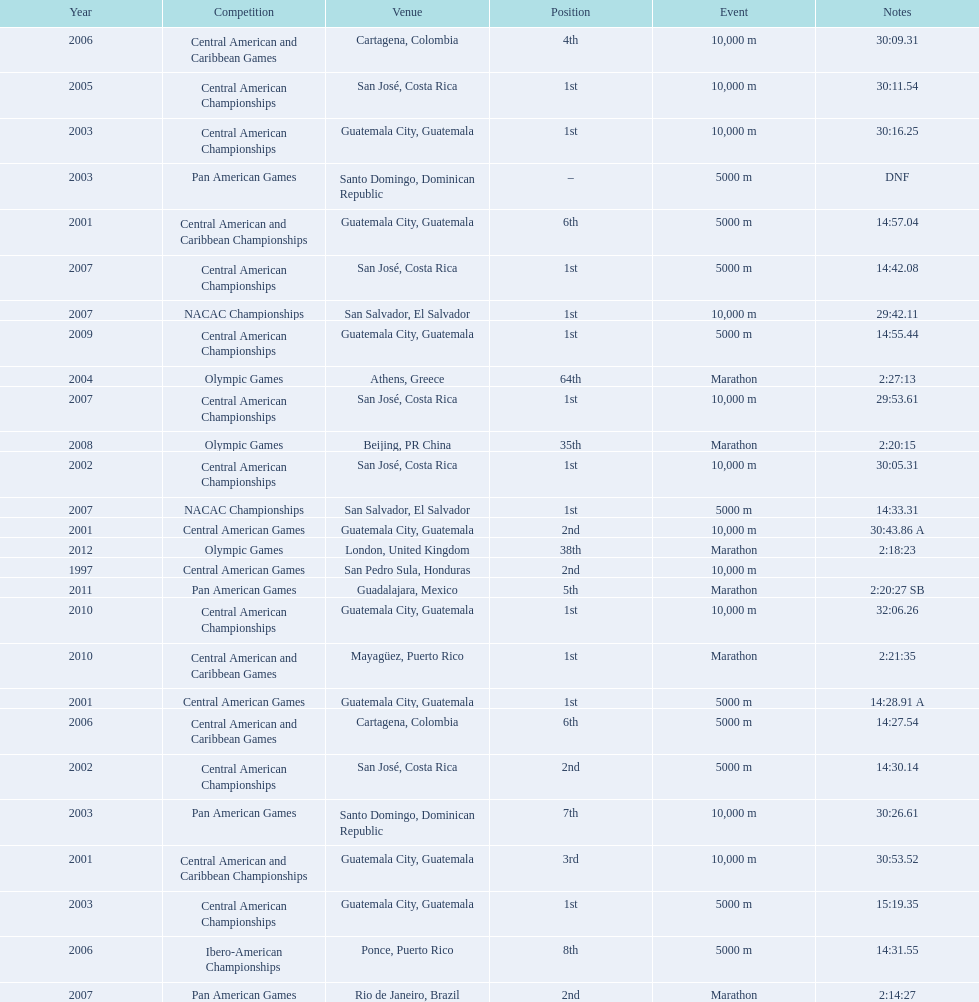Tell me the number of times they competed in guatamala. 5. 